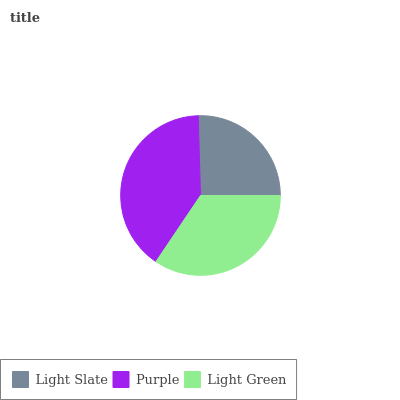Is Light Slate the minimum?
Answer yes or no. Yes. Is Purple the maximum?
Answer yes or no. Yes. Is Light Green the minimum?
Answer yes or no. No. Is Light Green the maximum?
Answer yes or no. No. Is Purple greater than Light Green?
Answer yes or no. Yes. Is Light Green less than Purple?
Answer yes or no. Yes. Is Light Green greater than Purple?
Answer yes or no. No. Is Purple less than Light Green?
Answer yes or no. No. Is Light Green the high median?
Answer yes or no. Yes. Is Light Green the low median?
Answer yes or no. Yes. Is Light Slate the high median?
Answer yes or no. No. Is Light Slate the low median?
Answer yes or no. No. 